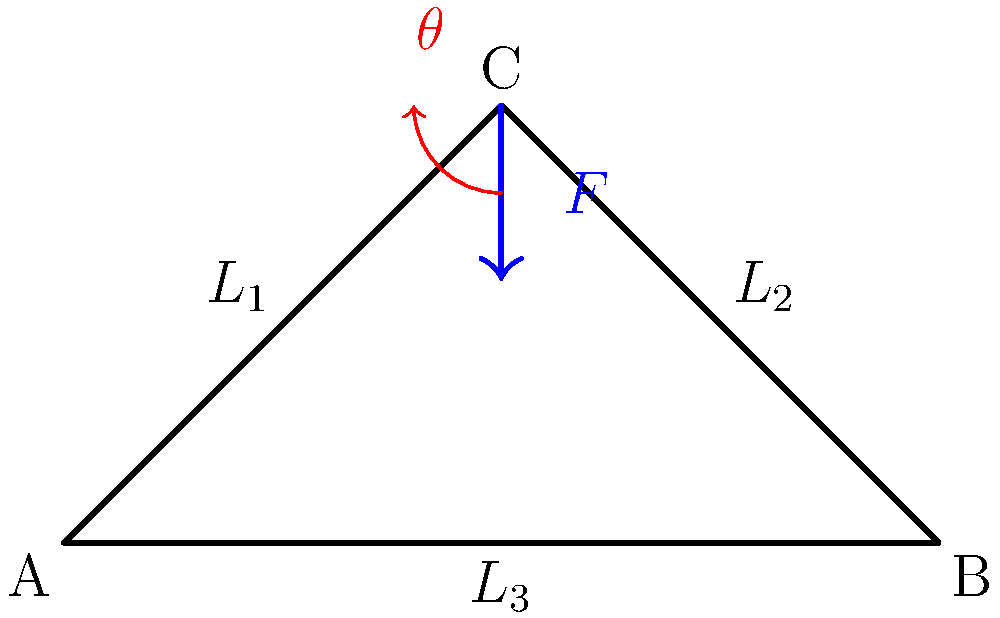В простой ферменной конструкции моста, как показано на рисунке, вертикальная сила $F$ приложена к вершине C. Если угол $\theta$ между горизонталью и элементом фермы $L_1$ составляет 60°, определите соотношение между силой сжатия в элементе $L_1$ и приложенной силой $F$. Предположите, что конструкция находится в равновесии. Для решения этой задачи выполним следующие шаги:

1) В равновесии сумма всех сил, действующих на узел C, должна быть равна нулю.

2) Разложим силы на вертикальные и горизонтальные компоненты:
   - Сила $F$ направлена вертикально вниз
   - Сила в элементе $L_1$ (назовем ее $F_1$) направлена под углом $\theta = 60°$ к горизонтали
   - Сила в элементе $L_2$ (назовем ее $F_2$) направлена симметрично $F_1$ из-за симметрии конструкции

3) Запишем уравнение равновесия для вертикальных сил:
   $$F = F_1 \sin 60° + F_2 \sin 60°$$

4) Из-за симметрии $F_1 = F_2$, поэтому:
   $$F = 2F_1 \sin 60°$$

5) Известно, что $\sin 60° = \frac{\sqrt{3}}{2}$, подставим:
   $$F = 2F_1 \cdot \frac{\sqrt{3}}{2} = F_1\sqrt{3}$$

6) Выразим $F_1$ через $F$:
   $$F_1 = \frac{F}{\sqrt{3}}$$

7) Отношение силы сжатия в элементе $L_1$ к приложенной силе $F$:
   $$\frac{F_1}{F} = \frac{1}{\sqrt{3}} \approx 0.577$$
Answer: $\frac{1}{\sqrt{3}}$ 